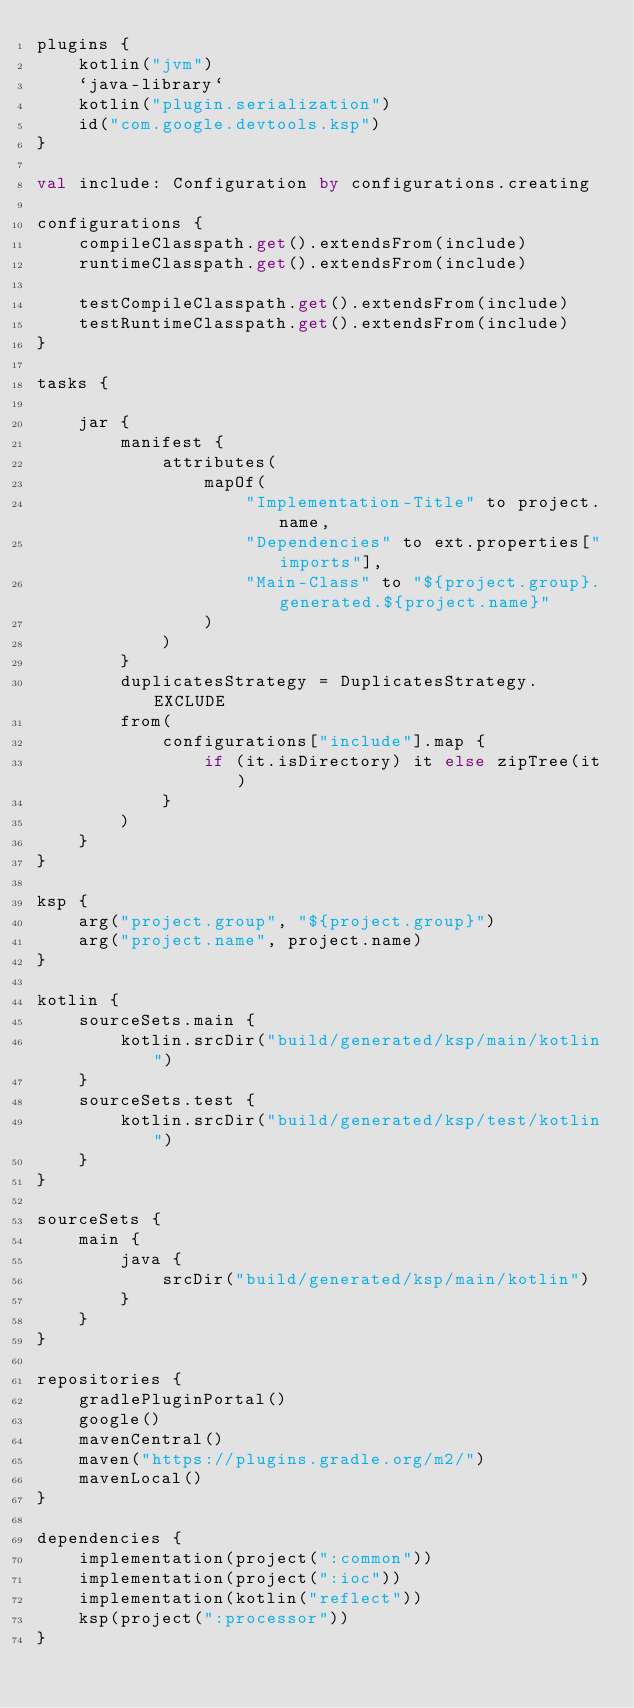<code> <loc_0><loc_0><loc_500><loc_500><_Kotlin_>plugins {
    kotlin("jvm")
    `java-library`
    kotlin("plugin.serialization")
    id("com.google.devtools.ksp")
}

val include: Configuration by configurations.creating

configurations {
    compileClasspath.get().extendsFrom(include)
    runtimeClasspath.get().extendsFrom(include)

    testCompileClasspath.get().extendsFrom(include)
    testRuntimeClasspath.get().extendsFrom(include)
}

tasks {

    jar {
        manifest {
            attributes(
                mapOf(
                    "Implementation-Title" to project.name,
                    "Dependencies" to ext.properties["imports"],
                    "Main-Class" to "${project.group}.generated.${project.name}"
                )
            )
        }
        duplicatesStrategy = DuplicatesStrategy.EXCLUDE
        from(
            configurations["include"].map {
                if (it.isDirectory) it else zipTree(it)
            }
        )
    }
}

ksp {
    arg("project.group", "${project.group}")
    arg("project.name", project.name)
}

kotlin {
    sourceSets.main {
        kotlin.srcDir("build/generated/ksp/main/kotlin")
    }
    sourceSets.test {
        kotlin.srcDir("build/generated/ksp/test/kotlin")
    }
}

sourceSets {
    main {
        java {
            srcDir("build/generated/ksp/main/kotlin")
        }
    }
}

repositories {
    gradlePluginPortal()
    google()
    mavenCentral()
    maven("https://plugins.gradle.org/m2/")
    mavenLocal()
}

dependencies {
    implementation(project(":common"))
    implementation(project(":ioc"))
    implementation(kotlin("reflect"))
    ksp(project(":processor"))
}
</code> 